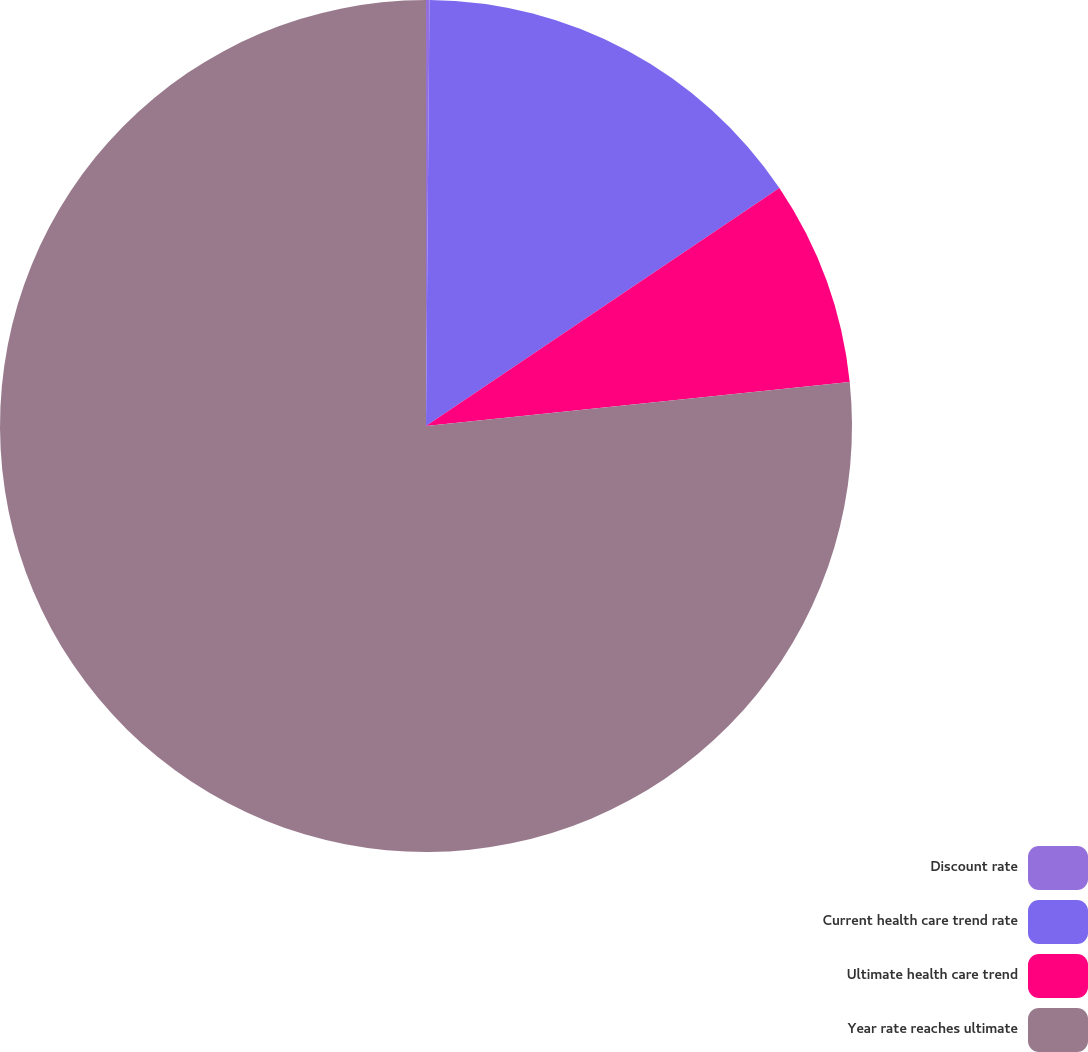Convert chart to OTSL. <chart><loc_0><loc_0><loc_500><loc_500><pie_chart><fcel>Discount rate<fcel>Current health care trend rate<fcel>Ultimate health care trend<fcel>Year rate reaches ultimate<nl><fcel>0.13%<fcel>15.44%<fcel>7.78%<fcel>76.65%<nl></chart> 